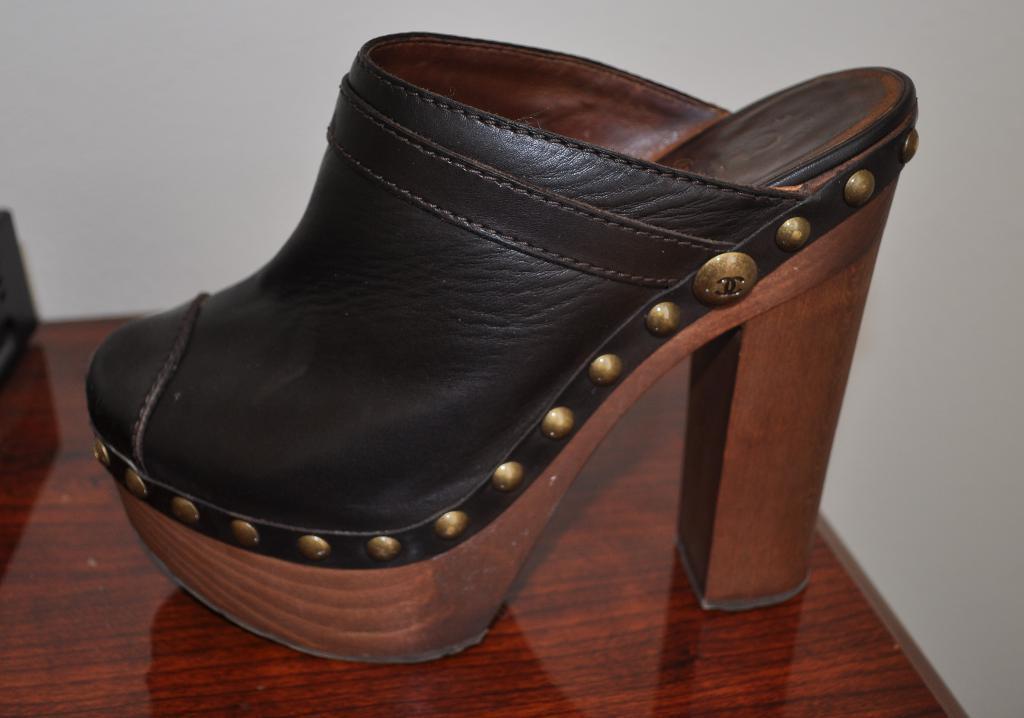Could you give a brief overview of what you see in this image? In this picture I can see a black and brown color footwear in front and it is on the brown color surface and it is white color in the background. 